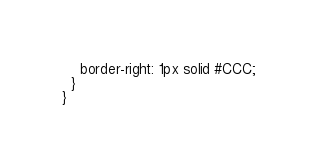<code> <loc_0><loc_0><loc_500><loc_500><_CSS_>    border-right: 1px solid #CCC;
  }
}</code> 